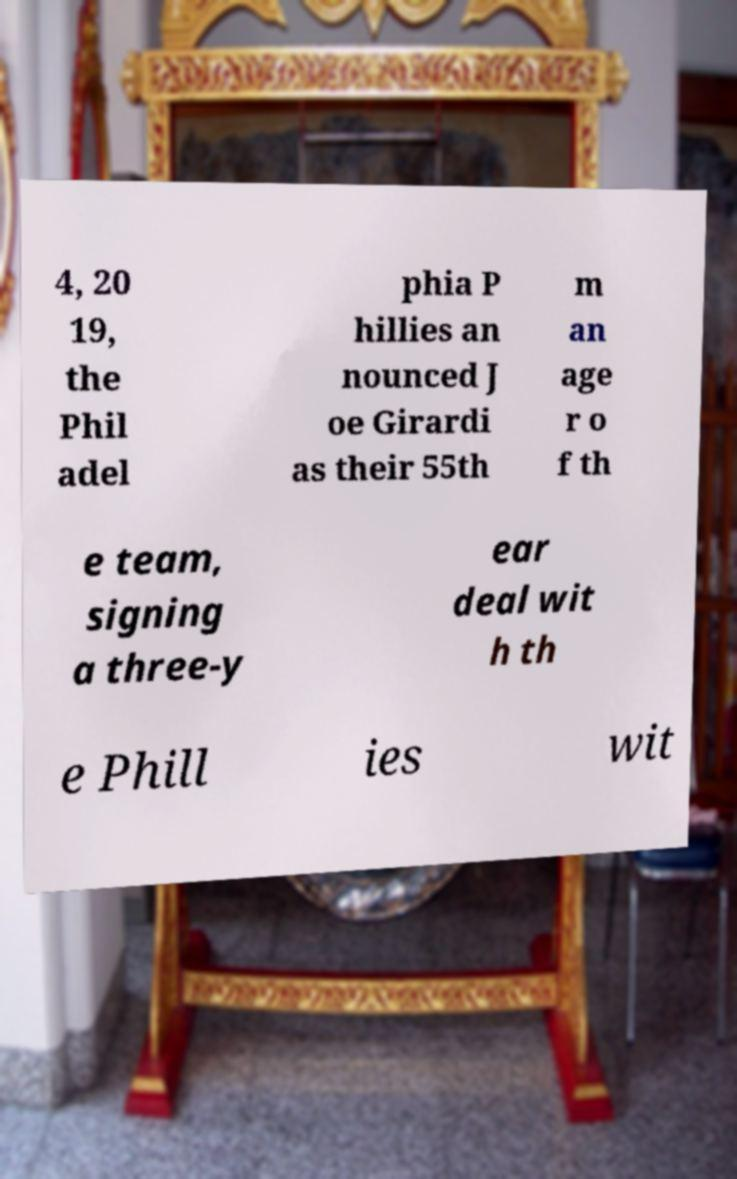Could you assist in decoding the text presented in this image and type it out clearly? 4, 20 19, the Phil adel phia P hillies an nounced J oe Girardi as their 55th m an age r o f th e team, signing a three-y ear deal wit h th e Phill ies wit 